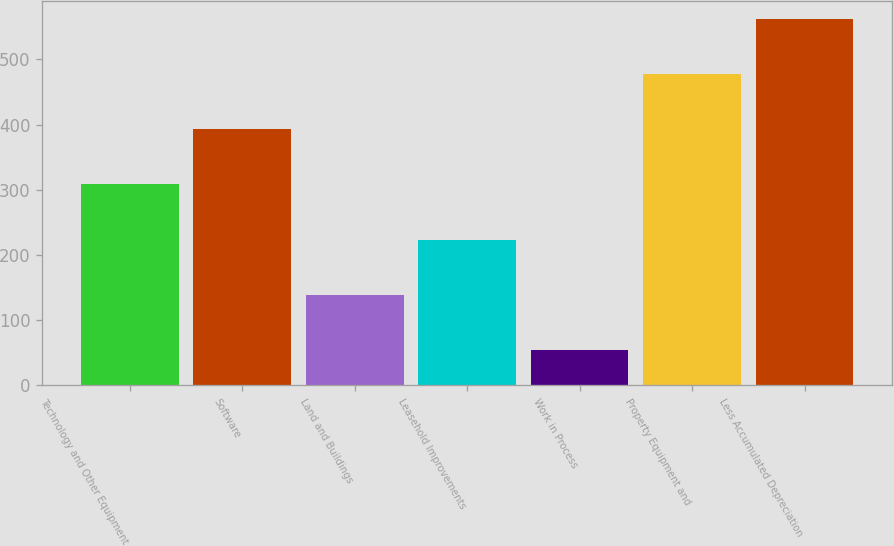Convert chart to OTSL. <chart><loc_0><loc_0><loc_500><loc_500><bar_chart><fcel>Technology and Other Equipment<fcel>Software<fcel>Land and Buildings<fcel>Leasehold Improvements<fcel>Work in Process<fcel>Property Equipment and<fcel>Less Accumulated Depreciation<nl><fcel>308.14<fcel>392.72<fcel>138.98<fcel>223.56<fcel>54.4<fcel>477.3<fcel>561.88<nl></chart> 